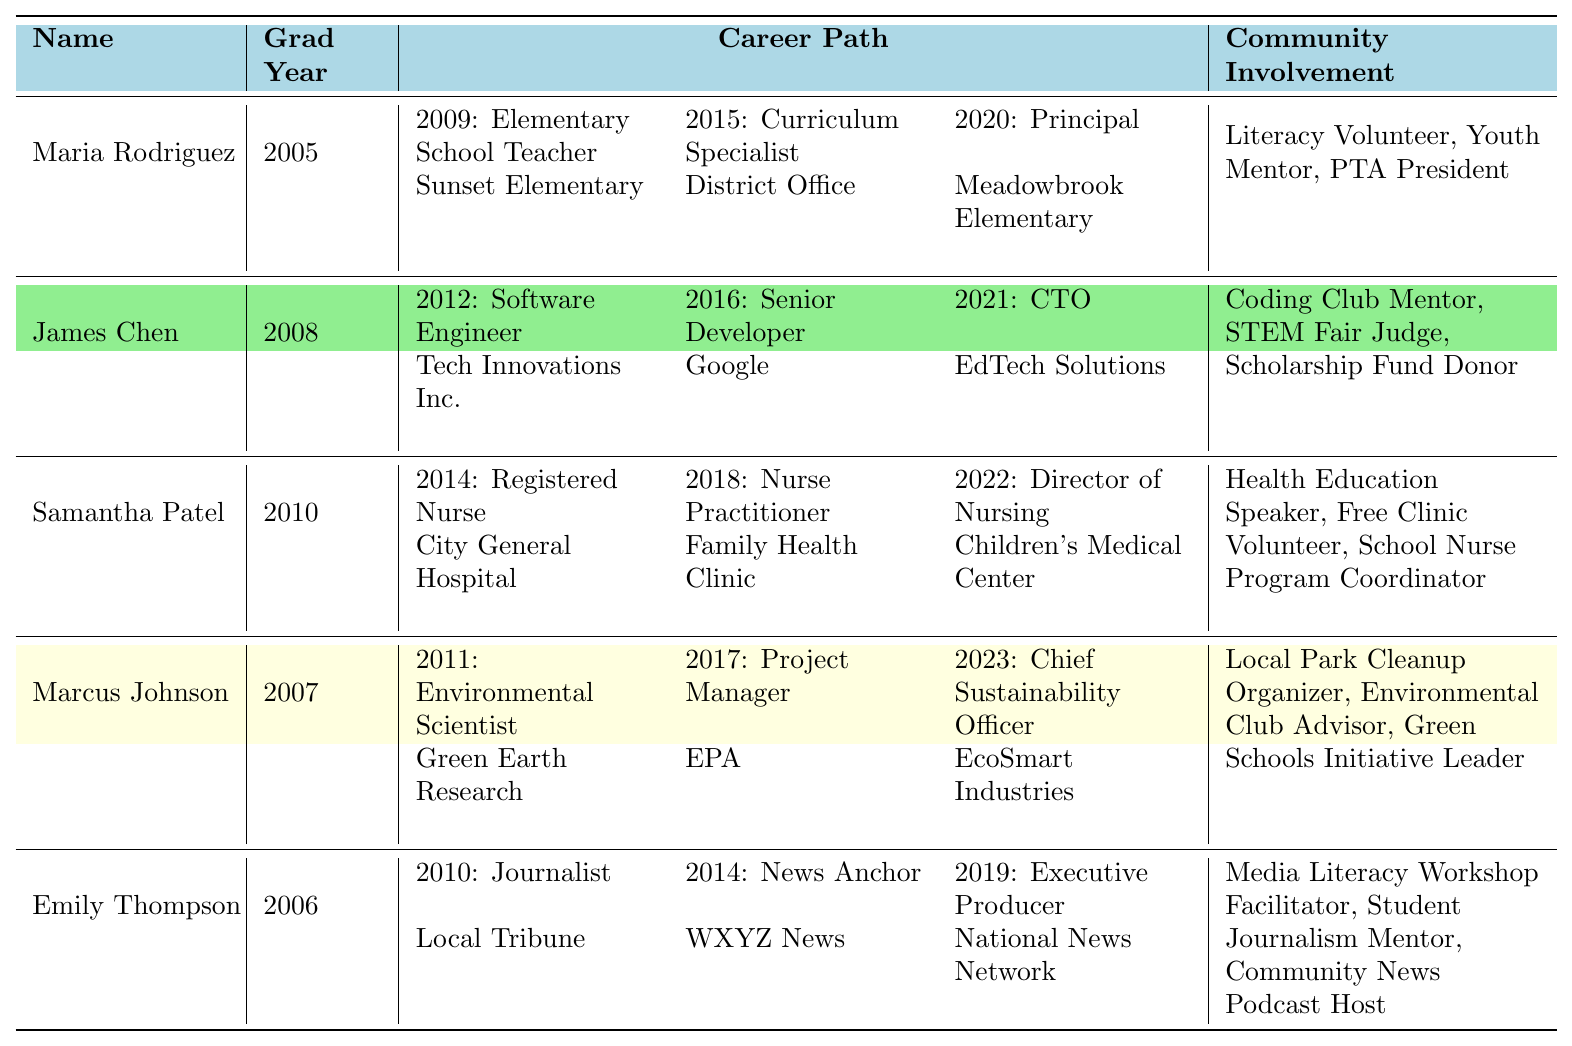What is the highest position achieved by Maria Rodriguez? Based on the career path entries for Maria Rodriguez, the highest position listed is Principal, which she achieved in 2020 at Meadowbrook Elementary.
Answer: Principal Which alumni graduated in 2010 and what was their first job? Looking at the graduation years, Samantha Patel graduated in 2010. Her first job listed is Registered Nurse at City General Hospital, which she started in 2014.
Answer: Registered Nurse Did any alumni serve as a PTA President? By reviewing the community involvement section of the table, it is noted that Maria Rodriguez served as a PTA President.
Answer: Yes Which two alumni transitioned to positions in healthcare and what were their final roles? The alumni in healthcare are Samantha Patel, who became the Director of Nursing at Children's Medical Center in 2022, and Maria Rodriguez, who, while primarily in education, contributed to health through community roles. Therefore, only Samantha has a direct healthcare final role, which is Director of Nursing.
Answer: Samantha Patel: Director of Nursing What was James Chen's position in 2016 and where did he work? From the data, James Chen's position in 2016 was Senior Developer and he worked at Google.
Answer: Senior Developer at Google Who has the earliest graduation year and what was their final career position? Maria Rodriguez has the earliest graduation year of 2005. Her final career position listed is Principal, achieved in 2020.
Answer: Principal What roles did Marcus Johnson hold between 2011 and 2023? Reviewing Marcus Johnson's career path: he started as an Environmental Scientist in 2011, became a Project Manager in 2017, and then was promoted to Chief Sustainability Officer in 2023.
Answer: Environmental Scientist, Project Manager, Chief Sustainability Officer How many community involvement activities did Emily Thompson participate in? Emily Thompson is noted to have been involved in three activities: Media Literacy Workshop Facilitator, Student Journalism Mentor, and Community News Podcast Host.
Answer: Three activities What was James Chen’s career position progression from 2012 to 2021? Beginning in 2012 as a Software Engineer, James Chen progressed to Senior Developer in 2016, and then he became CTO in 2021 at EdTech Solutions. Therefore, his roles show a clear progression upward.
Answer: Software Engineer, Senior Developer, CTO Which alumni worked for the EPA and what was their position? Marcus Johnson worked for the EPA as a Project Manager from 2017.
Answer: Project Manager 